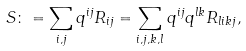<formula> <loc_0><loc_0><loc_500><loc_500>S \colon = \sum _ { i , j } q ^ { i j } R _ { i j } = \sum _ { i , j , k , l } q ^ { i j } q ^ { l k } R _ { l i k j } ,</formula> 